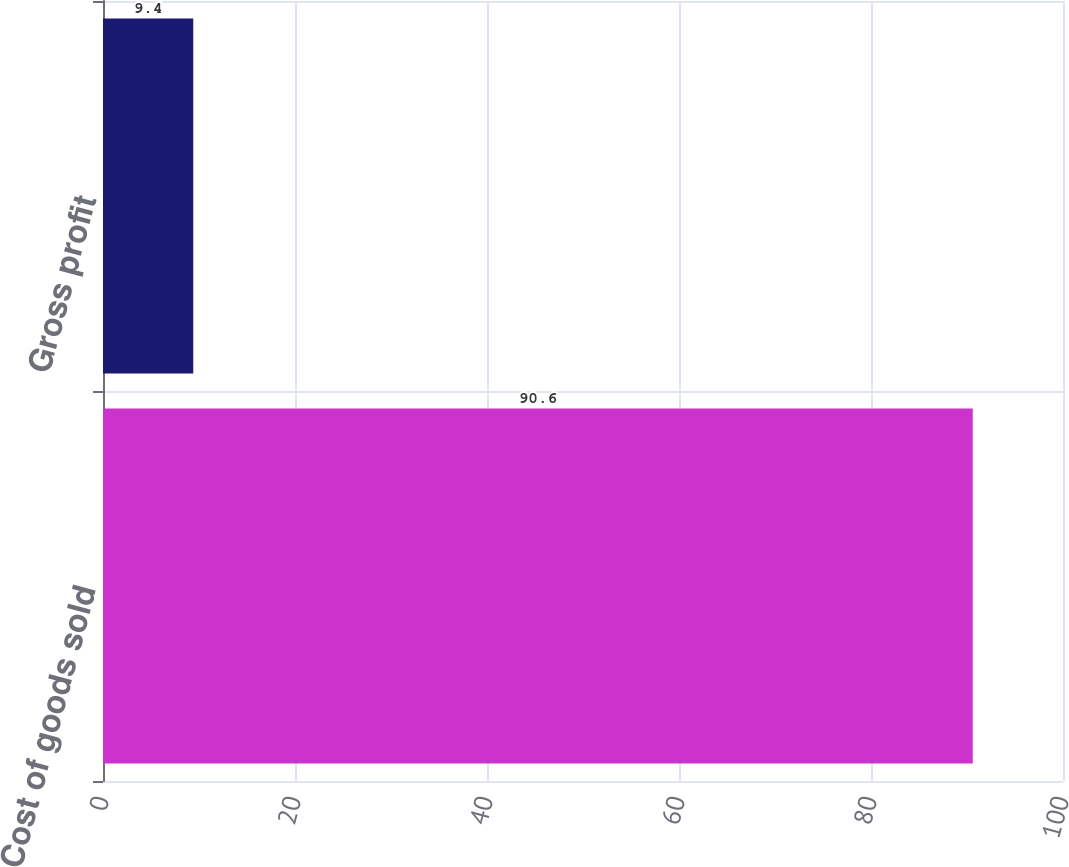<chart> <loc_0><loc_0><loc_500><loc_500><bar_chart><fcel>Cost of goods sold<fcel>Gross profit<nl><fcel>90.6<fcel>9.4<nl></chart> 